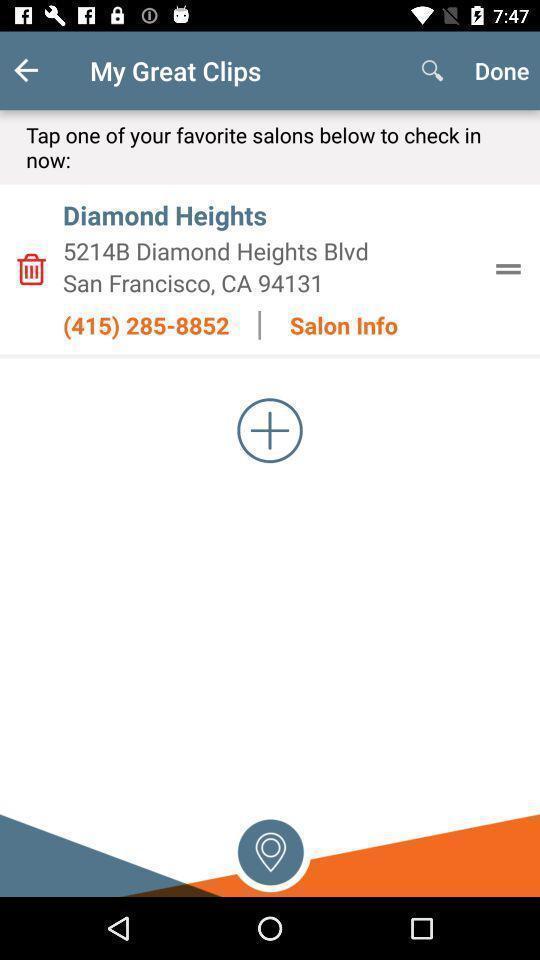Describe the content in this image. Screen displaying salon details. 